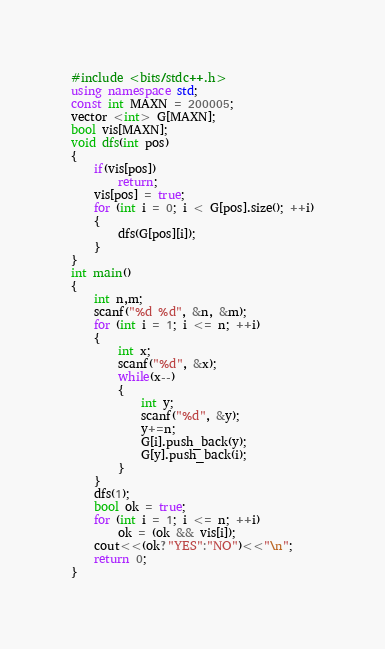Convert code to text. <code><loc_0><loc_0><loc_500><loc_500><_C++_>#include <bits/stdc++.h>
using namespace std;
const int MAXN = 200005;
vector <int> G[MAXN];
bool vis[MAXN];
void dfs(int pos)
{
	if(vis[pos])
		return;
	vis[pos] = true;
	for (int i = 0; i < G[pos].size(); ++i)
	{
		dfs(G[pos][i]);
	}
}
int main()
{
	int n,m;
	scanf("%d %d", &n, &m);
	for (int i = 1; i <= n; ++i)
	{
		int x;
		scanf("%d", &x);
		while(x--)
		{
			int y;
			scanf("%d", &y);
			y+=n;
			G[i].push_back(y);
			G[y].push_back(i);
		}
	}
	dfs(1);
	bool ok = true;
	for (int i = 1; i <= n; ++i)
		ok = (ok && vis[i]);
	cout<<(ok?"YES":"NO")<<"\n";
	return 0;
}</code> 